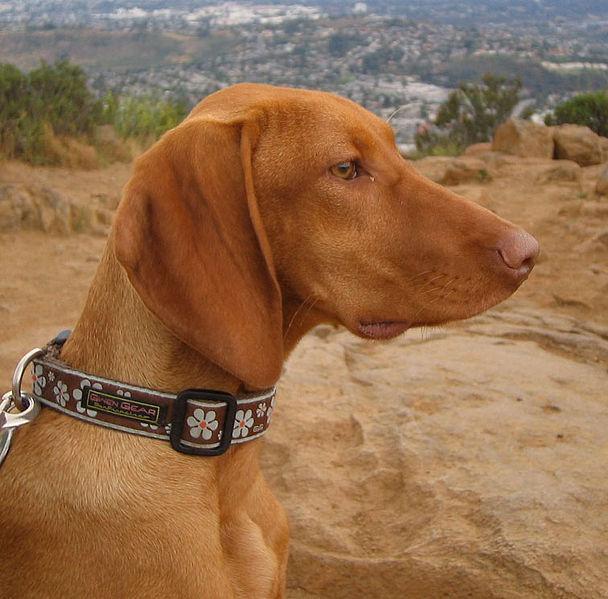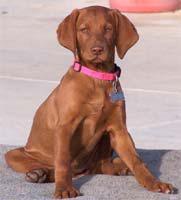The first image is the image on the left, the second image is the image on the right. For the images shown, is this caption "One dog's forehead is scrunched up." true? Answer yes or no. No. The first image is the image on the left, the second image is the image on the right. For the images shown, is this caption "There are two dogs in one image and one dog in the other image." true? Answer yes or no. No. 